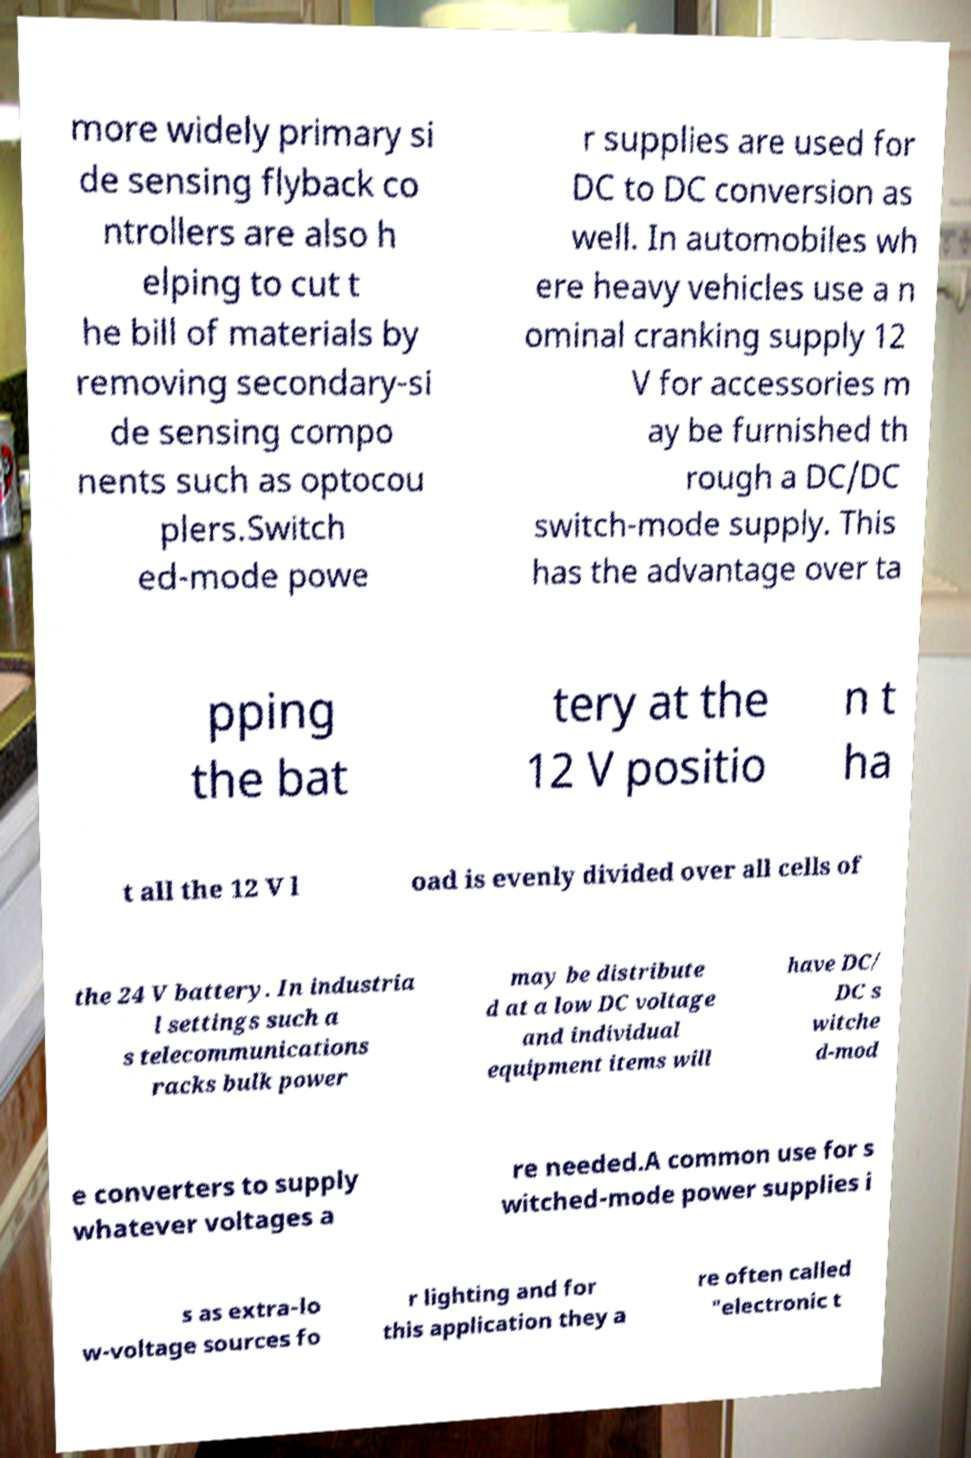I need the written content from this picture converted into text. Can you do that? more widely primary si de sensing flyback co ntrollers are also h elping to cut t he bill of materials by removing secondary-si de sensing compo nents such as optocou plers.Switch ed-mode powe r supplies are used for DC to DC conversion as well. In automobiles wh ere heavy vehicles use a n ominal cranking supply 12 V for accessories m ay be furnished th rough a DC/DC switch-mode supply. This has the advantage over ta pping the bat tery at the 12 V positio n t ha t all the 12 V l oad is evenly divided over all cells of the 24 V battery. In industria l settings such a s telecommunications racks bulk power may be distribute d at a low DC voltage and individual equipment items will have DC/ DC s witche d-mod e converters to supply whatever voltages a re needed.A common use for s witched-mode power supplies i s as extra-lo w-voltage sources fo r lighting and for this application they a re often called "electronic t 